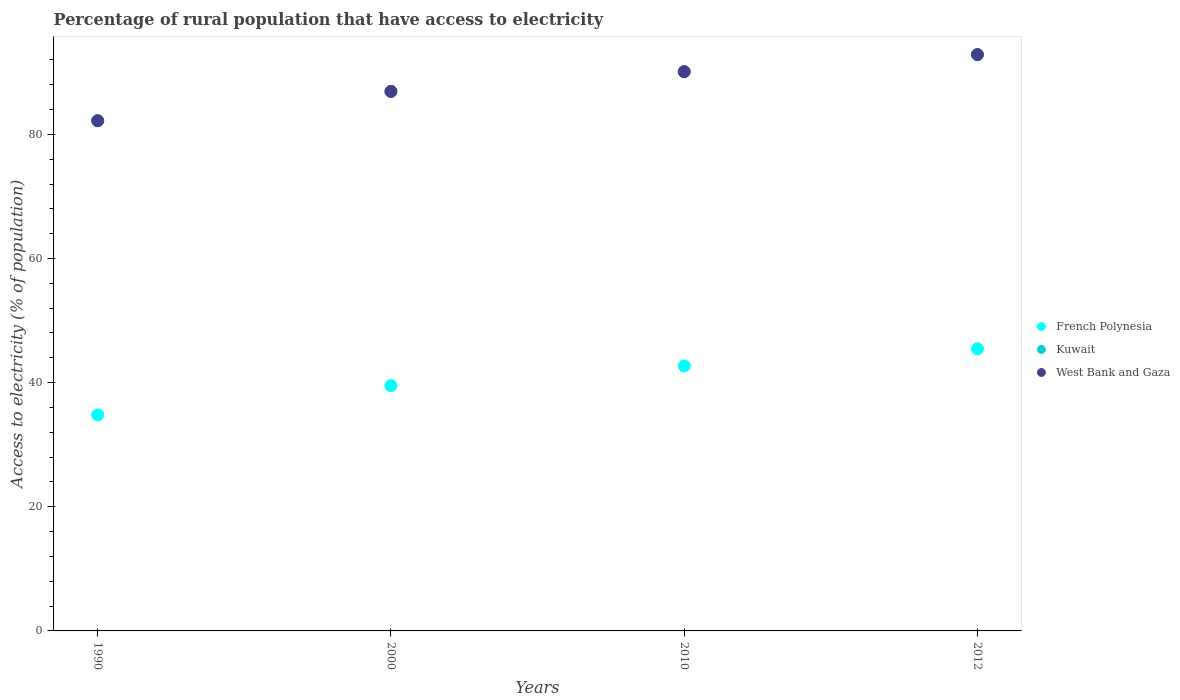How many different coloured dotlines are there?
Make the answer very short. 3. What is the percentage of rural population that have access to electricity in West Bank and Gaza in 2010?
Your response must be concise. 90.1. Across all years, what is the maximum percentage of rural population that have access to electricity in French Polynesia?
Offer a very short reply. 45.45. Across all years, what is the minimum percentage of rural population that have access to electricity in Kuwait?
Provide a succinct answer. 82.2. In which year was the percentage of rural population that have access to electricity in West Bank and Gaza minimum?
Offer a terse response. 1990. What is the total percentage of rural population that have access to electricity in West Bank and Gaza in the graph?
Keep it short and to the point. 352.08. What is the difference between the percentage of rural population that have access to electricity in West Bank and Gaza in 2000 and that in 2010?
Provide a succinct answer. -3.17. What is the difference between the percentage of rural population that have access to electricity in Kuwait in 2000 and the percentage of rural population that have access to electricity in French Polynesia in 2012?
Provide a succinct answer. 41.47. What is the average percentage of rural population that have access to electricity in Kuwait per year?
Keep it short and to the point. 88.02. In the year 2000, what is the difference between the percentage of rural population that have access to electricity in Kuwait and percentage of rural population that have access to electricity in French Polynesia?
Ensure brevity in your answer.  47.41. In how many years, is the percentage of rural population that have access to electricity in French Polynesia greater than 84 %?
Your answer should be very brief. 0. What is the ratio of the percentage of rural population that have access to electricity in Kuwait in 1990 to that in 2012?
Offer a terse response. 0.89. Is the percentage of rural population that have access to electricity in Kuwait in 2000 less than that in 2010?
Provide a succinct answer. Yes. Is the difference between the percentage of rural population that have access to electricity in Kuwait in 1990 and 2000 greater than the difference between the percentage of rural population that have access to electricity in French Polynesia in 1990 and 2000?
Your response must be concise. Yes. What is the difference between the highest and the second highest percentage of rural population that have access to electricity in French Polynesia?
Ensure brevity in your answer.  2.75. What is the difference between the highest and the lowest percentage of rural population that have access to electricity in West Bank and Gaza?
Make the answer very short. 10.65. Is it the case that in every year, the sum of the percentage of rural population that have access to electricity in Kuwait and percentage of rural population that have access to electricity in French Polynesia  is greater than the percentage of rural population that have access to electricity in West Bank and Gaza?
Your response must be concise. Yes. Does the percentage of rural population that have access to electricity in West Bank and Gaza monotonically increase over the years?
Your answer should be compact. Yes. Is the percentage of rural population that have access to electricity in West Bank and Gaza strictly greater than the percentage of rural population that have access to electricity in Kuwait over the years?
Keep it short and to the point. No. How many dotlines are there?
Give a very brief answer. 3. How many years are there in the graph?
Make the answer very short. 4. Does the graph contain any zero values?
Give a very brief answer. No. Does the graph contain grids?
Make the answer very short. No. Where does the legend appear in the graph?
Your answer should be very brief. Center right. How many legend labels are there?
Offer a terse response. 3. What is the title of the graph?
Your response must be concise. Percentage of rural population that have access to electricity. Does "Switzerland" appear as one of the legend labels in the graph?
Ensure brevity in your answer.  No. What is the label or title of the X-axis?
Keep it short and to the point. Years. What is the label or title of the Y-axis?
Your response must be concise. Access to electricity (% of population). What is the Access to electricity (% of population) in French Polynesia in 1990?
Offer a very short reply. 34.8. What is the Access to electricity (% of population) of Kuwait in 1990?
Provide a short and direct response. 82.2. What is the Access to electricity (% of population) in West Bank and Gaza in 1990?
Your answer should be very brief. 82.2. What is the Access to electricity (% of population) in French Polynesia in 2000?
Offer a terse response. 39.52. What is the Access to electricity (% of population) in Kuwait in 2000?
Your answer should be compact. 86.93. What is the Access to electricity (% of population) in West Bank and Gaza in 2000?
Keep it short and to the point. 86.93. What is the Access to electricity (% of population) of French Polynesia in 2010?
Make the answer very short. 42.7. What is the Access to electricity (% of population) in Kuwait in 2010?
Give a very brief answer. 90.1. What is the Access to electricity (% of population) in West Bank and Gaza in 2010?
Give a very brief answer. 90.1. What is the Access to electricity (% of population) of French Polynesia in 2012?
Offer a terse response. 45.45. What is the Access to electricity (% of population) in Kuwait in 2012?
Ensure brevity in your answer.  92.85. What is the Access to electricity (% of population) in West Bank and Gaza in 2012?
Ensure brevity in your answer.  92.85. Across all years, what is the maximum Access to electricity (% of population) of French Polynesia?
Provide a succinct answer. 45.45. Across all years, what is the maximum Access to electricity (% of population) in Kuwait?
Make the answer very short. 92.85. Across all years, what is the maximum Access to electricity (% of population) in West Bank and Gaza?
Keep it short and to the point. 92.85. Across all years, what is the minimum Access to electricity (% of population) in French Polynesia?
Make the answer very short. 34.8. Across all years, what is the minimum Access to electricity (% of population) in Kuwait?
Make the answer very short. 82.2. Across all years, what is the minimum Access to electricity (% of population) in West Bank and Gaza?
Your answer should be very brief. 82.2. What is the total Access to electricity (% of population) of French Polynesia in the graph?
Your answer should be very brief. 162.47. What is the total Access to electricity (% of population) of Kuwait in the graph?
Offer a terse response. 352.08. What is the total Access to electricity (% of population) in West Bank and Gaza in the graph?
Give a very brief answer. 352.08. What is the difference between the Access to electricity (% of population) of French Polynesia in 1990 and that in 2000?
Your answer should be compact. -4.72. What is the difference between the Access to electricity (% of population) of Kuwait in 1990 and that in 2000?
Provide a short and direct response. -4.72. What is the difference between the Access to electricity (% of population) in West Bank and Gaza in 1990 and that in 2000?
Keep it short and to the point. -4.72. What is the difference between the Access to electricity (% of population) in French Polynesia in 1990 and that in 2010?
Make the answer very short. -7.9. What is the difference between the Access to electricity (% of population) in Kuwait in 1990 and that in 2010?
Make the answer very short. -7.9. What is the difference between the Access to electricity (% of population) in West Bank and Gaza in 1990 and that in 2010?
Give a very brief answer. -7.9. What is the difference between the Access to electricity (% of population) of French Polynesia in 1990 and that in 2012?
Keep it short and to the point. -10.66. What is the difference between the Access to electricity (% of population) in Kuwait in 1990 and that in 2012?
Offer a very short reply. -10.65. What is the difference between the Access to electricity (% of population) in West Bank and Gaza in 1990 and that in 2012?
Make the answer very short. -10.65. What is the difference between the Access to electricity (% of population) of French Polynesia in 2000 and that in 2010?
Provide a succinct answer. -3.18. What is the difference between the Access to electricity (% of population) of Kuwait in 2000 and that in 2010?
Your response must be concise. -3.17. What is the difference between the Access to electricity (% of population) in West Bank and Gaza in 2000 and that in 2010?
Your answer should be compact. -3.17. What is the difference between the Access to electricity (% of population) in French Polynesia in 2000 and that in 2012?
Offer a very short reply. -5.93. What is the difference between the Access to electricity (% of population) in Kuwait in 2000 and that in 2012?
Give a very brief answer. -5.93. What is the difference between the Access to electricity (% of population) in West Bank and Gaza in 2000 and that in 2012?
Your response must be concise. -5.93. What is the difference between the Access to electricity (% of population) of French Polynesia in 2010 and that in 2012?
Offer a terse response. -2.75. What is the difference between the Access to electricity (% of population) in Kuwait in 2010 and that in 2012?
Your answer should be very brief. -2.75. What is the difference between the Access to electricity (% of population) in West Bank and Gaza in 2010 and that in 2012?
Make the answer very short. -2.75. What is the difference between the Access to electricity (% of population) of French Polynesia in 1990 and the Access to electricity (% of population) of Kuwait in 2000?
Offer a terse response. -52.13. What is the difference between the Access to electricity (% of population) in French Polynesia in 1990 and the Access to electricity (% of population) in West Bank and Gaza in 2000?
Ensure brevity in your answer.  -52.13. What is the difference between the Access to electricity (% of population) of Kuwait in 1990 and the Access to electricity (% of population) of West Bank and Gaza in 2000?
Make the answer very short. -4.72. What is the difference between the Access to electricity (% of population) of French Polynesia in 1990 and the Access to electricity (% of population) of Kuwait in 2010?
Ensure brevity in your answer.  -55.3. What is the difference between the Access to electricity (% of population) in French Polynesia in 1990 and the Access to electricity (% of population) in West Bank and Gaza in 2010?
Keep it short and to the point. -55.3. What is the difference between the Access to electricity (% of population) of Kuwait in 1990 and the Access to electricity (% of population) of West Bank and Gaza in 2010?
Provide a succinct answer. -7.9. What is the difference between the Access to electricity (% of population) in French Polynesia in 1990 and the Access to electricity (% of population) in Kuwait in 2012?
Provide a short and direct response. -58.06. What is the difference between the Access to electricity (% of population) in French Polynesia in 1990 and the Access to electricity (% of population) in West Bank and Gaza in 2012?
Offer a terse response. -58.06. What is the difference between the Access to electricity (% of population) in Kuwait in 1990 and the Access to electricity (% of population) in West Bank and Gaza in 2012?
Provide a succinct answer. -10.65. What is the difference between the Access to electricity (% of population) of French Polynesia in 2000 and the Access to electricity (% of population) of Kuwait in 2010?
Your response must be concise. -50.58. What is the difference between the Access to electricity (% of population) in French Polynesia in 2000 and the Access to electricity (% of population) in West Bank and Gaza in 2010?
Your answer should be very brief. -50.58. What is the difference between the Access to electricity (% of population) in Kuwait in 2000 and the Access to electricity (% of population) in West Bank and Gaza in 2010?
Offer a very short reply. -3.17. What is the difference between the Access to electricity (% of population) of French Polynesia in 2000 and the Access to electricity (% of population) of Kuwait in 2012?
Your answer should be compact. -53.33. What is the difference between the Access to electricity (% of population) in French Polynesia in 2000 and the Access to electricity (% of population) in West Bank and Gaza in 2012?
Offer a very short reply. -53.33. What is the difference between the Access to electricity (% of population) in Kuwait in 2000 and the Access to electricity (% of population) in West Bank and Gaza in 2012?
Provide a succinct answer. -5.93. What is the difference between the Access to electricity (% of population) in French Polynesia in 2010 and the Access to electricity (% of population) in Kuwait in 2012?
Offer a terse response. -50.15. What is the difference between the Access to electricity (% of population) in French Polynesia in 2010 and the Access to electricity (% of population) in West Bank and Gaza in 2012?
Your answer should be compact. -50.15. What is the difference between the Access to electricity (% of population) in Kuwait in 2010 and the Access to electricity (% of population) in West Bank and Gaza in 2012?
Provide a succinct answer. -2.75. What is the average Access to electricity (% of population) in French Polynesia per year?
Give a very brief answer. 40.62. What is the average Access to electricity (% of population) of Kuwait per year?
Make the answer very short. 88.02. What is the average Access to electricity (% of population) of West Bank and Gaza per year?
Offer a terse response. 88.02. In the year 1990, what is the difference between the Access to electricity (% of population) in French Polynesia and Access to electricity (% of population) in Kuwait?
Offer a very short reply. -47.41. In the year 1990, what is the difference between the Access to electricity (% of population) in French Polynesia and Access to electricity (% of population) in West Bank and Gaza?
Keep it short and to the point. -47.41. In the year 2000, what is the difference between the Access to electricity (% of population) in French Polynesia and Access to electricity (% of population) in Kuwait?
Offer a very short reply. -47.41. In the year 2000, what is the difference between the Access to electricity (% of population) of French Polynesia and Access to electricity (% of population) of West Bank and Gaza?
Your answer should be compact. -47.41. In the year 2010, what is the difference between the Access to electricity (% of population) of French Polynesia and Access to electricity (% of population) of Kuwait?
Your answer should be compact. -47.4. In the year 2010, what is the difference between the Access to electricity (% of population) in French Polynesia and Access to electricity (% of population) in West Bank and Gaza?
Your response must be concise. -47.4. In the year 2012, what is the difference between the Access to electricity (% of population) of French Polynesia and Access to electricity (% of population) of Kuwait?
Offer a terse response. -47.4. In the year 2012, what is the difference between the Access to electricity (% of population) of French Polynesia and Access to electricity (% of population) of West Bank and Gaza?
Offer a terse response. -47.4. What is the ratio of the Access to electricity (% of population) of French Polynesia in 1990 to that in 2000?
Provide a short and direct response. 0.88. What is the ratio of the Access to electricity (% of population) of Kuwait in 1990 to that in 2000?
Provide a succinct answer. 0.95. What is the ratio of the Access to electricity (% of population) in West Bank and Gaza in 1990 to that in 2000?
Ensure brevity in your answer.  0.95. What is the ratio of the Access to electricity (% of population) of French Polynesia in 1990 to that in 2010?
Your answer should be compact. 0.81. What is the ratio of the Access to electricity (% of population) of Kuwait in 1990 to that in 2010?
Your response must be concise. 0.91. What is the ratio of the Access to electricity (% of population) of West Bank and Gaza in 1990 to that in 2010?
Provide a short and direct response. 0.91. What is the ratio of the Access to electricity (% of population) of French Polynesia in 1990 to that in 2012?
Ensure brevity in your answer.  0.77. What is the ratio of the Access to electricity (% of population) of Kuwait in 1990 to that in 2012?
Offer a very short reply. 0.89. What is the ratio of the Access to electricity (% of population) of West Bank and Gaza in 1990 to that in 2012?
Keep it short and to the point. 0.89. What is the ratio of the Access to electricity (% of population) of French Polynesia in 2000 to that in 2010?
Provide a succinct answer. 0.93. What is the ratio of the Access to electricity (% of population) in Kuwait in 2000 to that in 2010?
Offer a terse response. 0.96. What is the ratio of the Access to electricity (% of population) of West Bank and Gaza in 2000 to that in 2010?
Provide a succinct answer. 0.96. What is the ratio of the Access to electricity (% of population) of French Polynesia in 2000 to that in 2012?
Your response must be concise. 0.87. What is the ratio of the Access to electricity (% of population) of Kuwait in 2000 to that in 2012?
Provide a short and direct response. 0.94. What is the ratio of the Access to electricity (% of population) of West Bank and Gaza in 2000 to that in 2012?
Your response must be concise. 0.94. What is the ratio of the Access to electricity (% of population) of French Polynesia in 2010 to that in 2012?
Ensure brevity in your answer.  0.94. What is the ratio of the Access to electricity (% of population) of Kuwait in 2010 to that in 2012?
Your answer should be compact. 0.97. What is the ratio of the Access to electricity (% of population) of West Bank and Gaza in 2010 to that in 2012?
Provide a succinct answer. 0.97. What is the difference between the highest and the second highest Access to electricity (% of population) of French Polynesia?
Provide a short and direct response. 2.75. What is the difference between the highest and the second highest Access to electricity (% of population) in Kuwait?
Your answer should be very brief. 2.75. What is the difference between the highest and the second highest Access to electricity (% of population) in West Bank and Gaza?
Offer a very short reply. 2.75. What is the difference between the highest and the lowest Access to electricity (% of population) in French Polynesia?
Ensure brevity in your answer.  10.66. What is the difference between the highest and the lowest Access to electricity (% of population) in Kuwait?
Your answer should be very brief. 10.65. What is the difference between the highest and the lowest Access to electricity (% of population) of West Bank and Gaza?
Offer a very short reply. 10.65. 